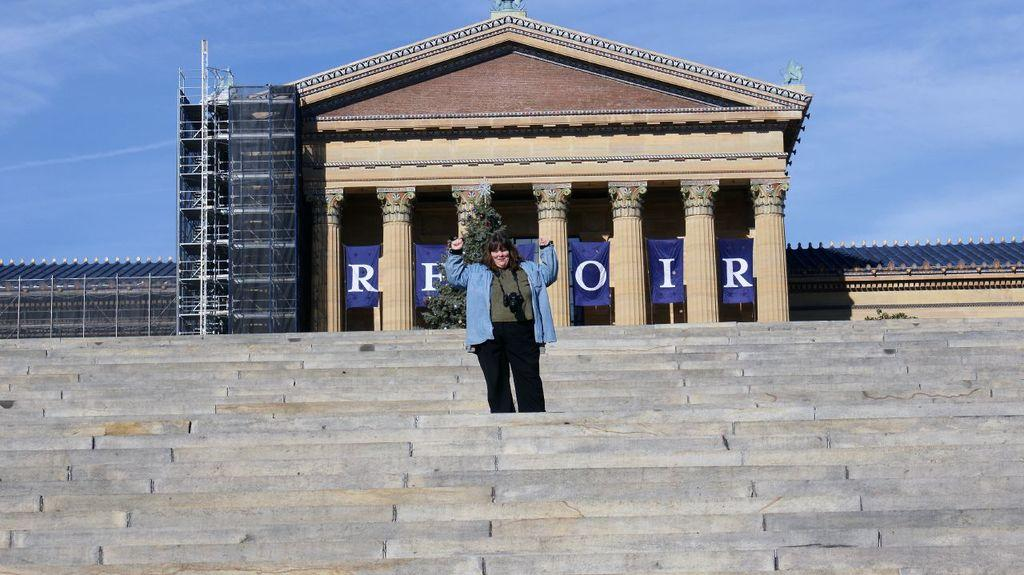What is the person in the image holding? The person in the image is holding a camera. What architectural feature can be seen in the image? There are stairs and a building with pillars in the image. What type of signage is present in the image? There is a poster with text in the image. What type of barrier is present in the image? There is fencing in the image. What type of vegetation is present in the image? There is a plant in the image. What type of structure is present in the image? There is a shed in the image. What can be seen in the sky in the image? The sky with clouds is visible in the image. Can you tell me how many snakes are slithering around the plant in the image? There are no snakes present in the image; only a plant can be seen. What type of bun is the person in the image eating? There is no bun present in the image; the person is holding a camera. 